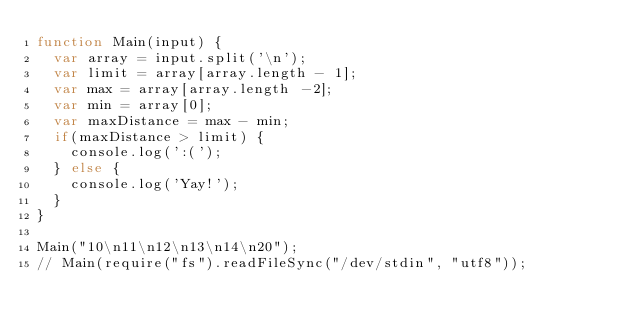Convert code to text. <code><loc_0><loc_0><loc_500><loc_500><_JavaScript_>function Main(input) {
  var array = input.split('\n');
  var limit = array[array.length - 1];
  var max = array[array.length -2];
  var min = array[0];
  var maxDistance = max - min;
  if(maxDistance > limit) {
    console.log(':(');
  } else {
    console.log('Yay!');
  }
}

Main("10\n11\n12\n13\n14\n20");
// Main(require("fs").readFileSync("/dev/stdin", "utf8"));
</code> 